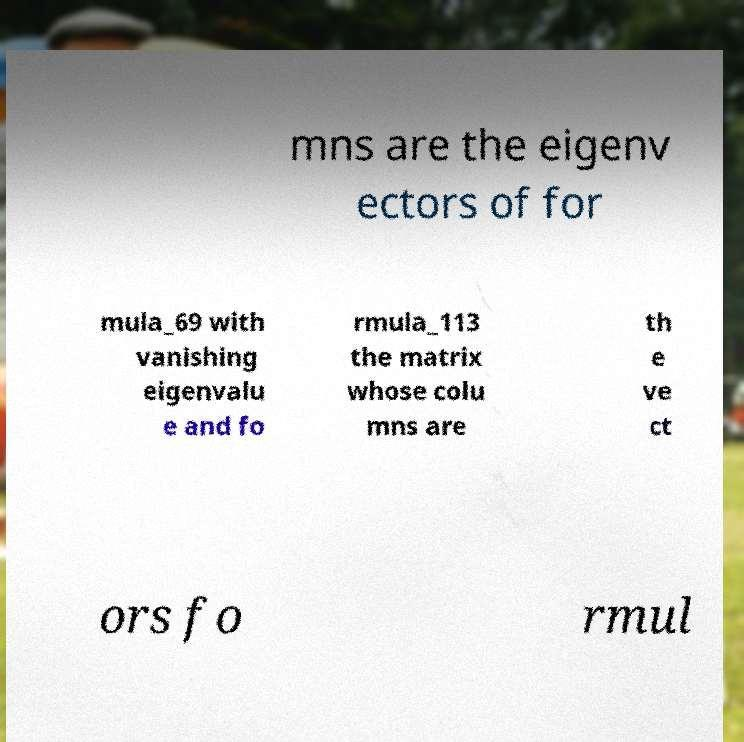I need the written content from this picture converted into text. Can you do that? mns are the eigenv ectors of for mula_69 with vanishing eigenvalu e and fo rmula_113 the matrix whose colu mns are th e ve ct ors fo rmul 